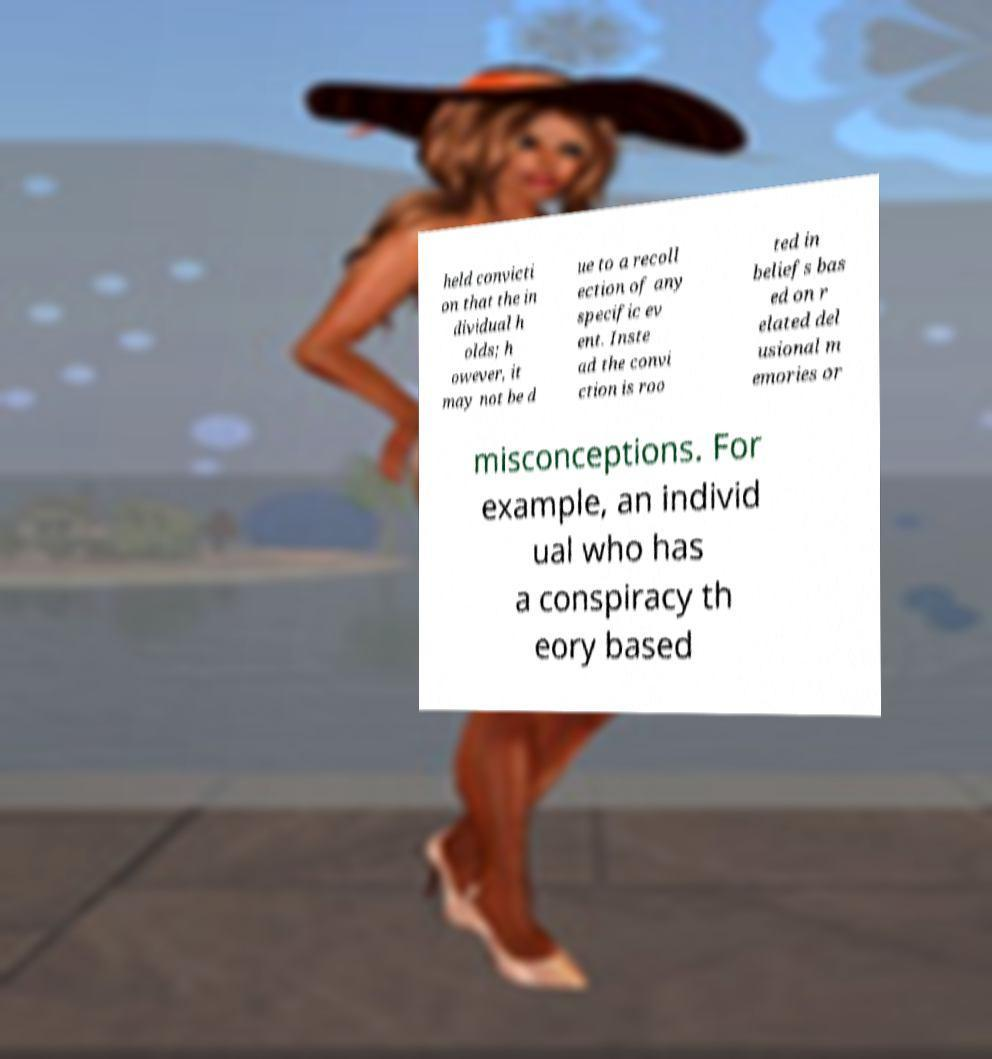Please read and relay the text visible in this image. What does it say? held convicti on that the in dividual h olds; h owever, it may not be d ue to a recoll ection of any specific ev ent. Inste ad the convi ction is roo ted in beliefs bas ed on r elated del usional m emories or misconceptions. For example, an individ ual who has a conspiracy th eory based 